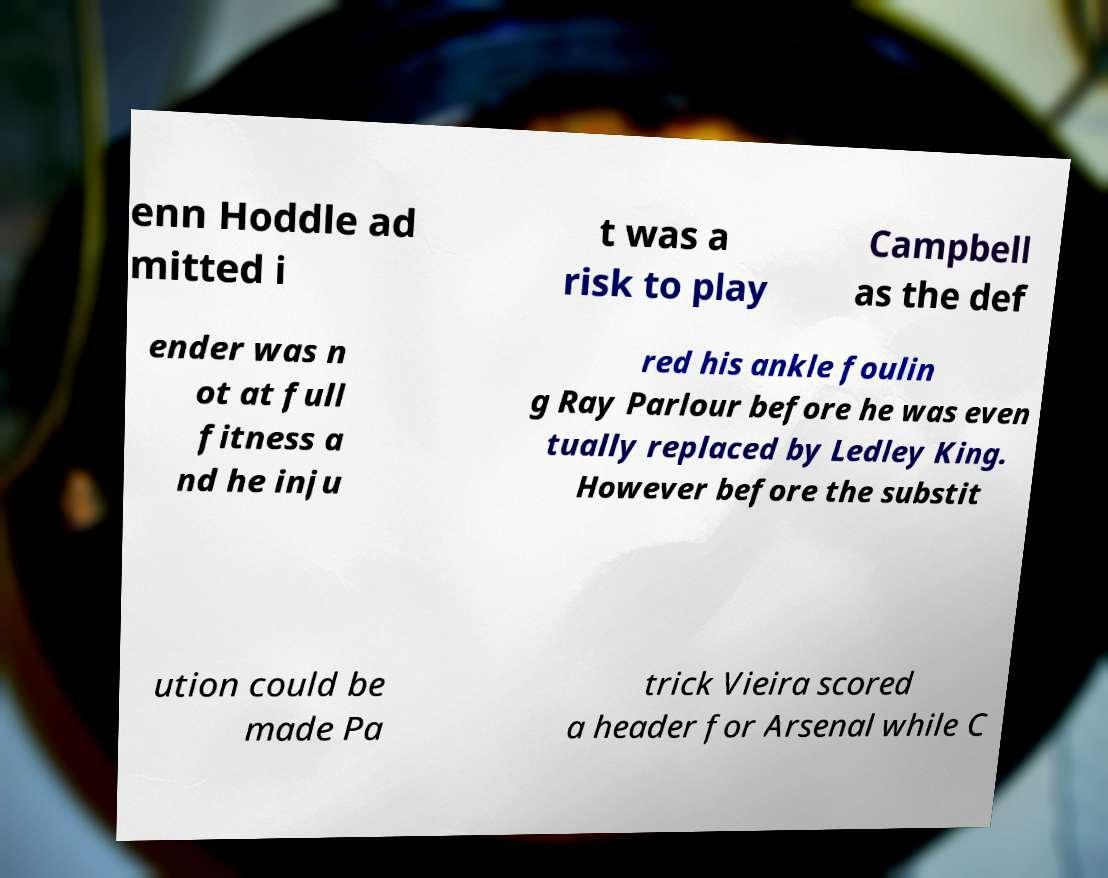Could you extract and type out the text from this image? enn Hoddle ad mitted i t was a risk to play Campbell as the def ender was n ot at full fitness a nd he inju red his ankle foulin g Ray Parlour before he was even tually replaced by Ledley King. However before the substit ution could be made Pa trick Vieira scored a header for Arsenal while C 